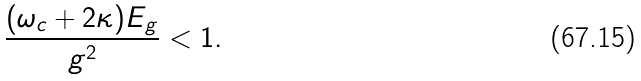<formula> <loc_0><loc_0><loc_500><loc_500>\frac { ( \omega _ { c } + 2 \kappa ) E _ { g } } { g ^ { 2 } } < 1 .</formula> 